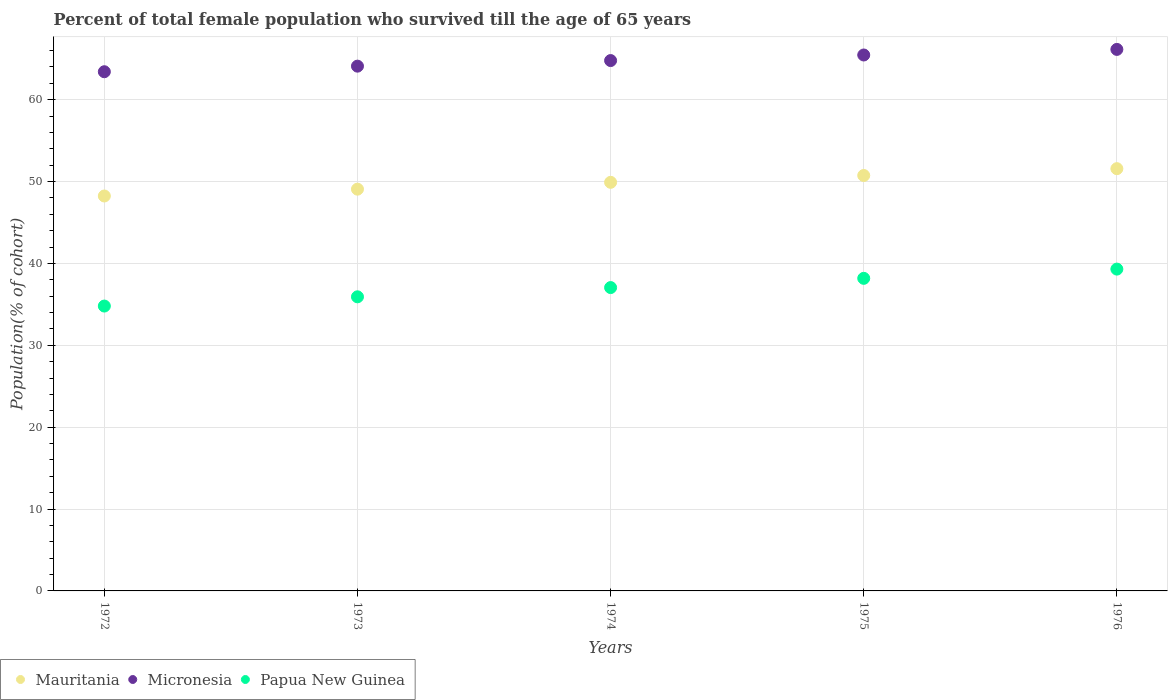What is the percentage of total female population who survived till the age of 65 years in Micronesia in 1976?
Your answer should be compact. 66.14. Across all years, what is the maximum percentage of total female population who survived till the age of 65 years in Papua New Guinea?
Make the answer very short. 39.31. Across all years, what is the minimum percentage of total female population who survived till the age of 65 years in Mauritania?
Give a very brief answer. 48.24. In which year was the percentage of total female population who survived till the age of 65 years in Mauritania maximum?
Your answer should be compact. 1976. What is the total percentage of total female population who survived till the age of 65 years in Mauritania in the graph?
Ensure brevity in your answer.  249.53. What is the difference between the percentage of total female population who survived till the age of 65 years in Micronesia in 1972 and that in 1975?
Offer a very short reply. -2.05. What is the difference between the percentage of total female population who survived till the age of 65 years in Mauritania in 1973 and the percentage of total female population who survived till the age of 65 years in Micronesia in 1974?
Give a very brief answer. -15.71. What is the average percentage of total female population who survived till the age of 65 years in Papua New Guinea per year?
Provide a short and direct response. 37.05. In the year 1975, what is the difference between the percentage of total female population who survived till the age of 65 years in Micronesia and percentage of total female population who survived till the age of 65 years in Mauritania?
Offer a very short reply. 14.72. What is the ratio of the percentage of total female population who survived till the age of 65 years in Papua New Guinea in 1974 to that in 1975?
Offer a very short reply. 0.97. What is the difference between the highest and the second highest percentage of total female population who survived till the age of 65 years in Mauritania?
Provide a short and direct response. 0.83. What is the difference between the highest and the lowest percentage of total female population who survived till the age of 65 years in Micronesia?
Provide a succinct answer. 2.73. Is the sum of the percentage of total female population who survived till the age of 65 years in Papua New Guinea in 1975 and 1976 greater than the maximum percentage of total female population who survived till the age of 65 years in Mauritania across all years?
Offer a very short reply. Yes. Is it the case that in every year, the sum of the percentage of total female population who survived till the age of 65 years in Papua New Guinea and percentage of total female population who survived till the age of 65 years in Mauritania  is greater than the percentage of total female population who survived till the age of 65 years in Micronesia?
Offer a terse response. Yes. Does the percentage of total female population who survived till the age of 65 years in Micronesia monotonically increase over the years?
Make the answer very short. Yes. Is the percentage of total female population who survived till the age of 65 years in Papua New Guinea strictly greater than the percentage of total female population who survived till the age of 65 years in Mauritania over the years?
Ensure brevity in your answer.  No. How many dotlines are there?
Your answer should be compact. 3. How many years are there in the graph?
Offer a very short reply. 5. Are the values on the major ticks of Y-axis written in scientific E-notation?
Offer a terse response. No. Does the graph contain any zero values?
Your answer should be very brief. No. What is the title of the graph?
Offer a terse response. Percent of total female population who survived till the age of 65 years. What is the label or title of the X-axis?
Your answer should be compact. Years. What is the label or title of the Y-axis?
Provide a short and direct response. Population(% of cohort). What is the Population(% of cohort) of Mauritania in 1972?
Make the answer very short. 48.24. What is the Population(% of cohort) of Micronesia in 1972?
Provide a succinct answer. 63.41. What is the Population(% of cohort) in Papua New Guinea in 1972?
Make the answer very short. 34.79. What is the Population(% of cohort) in Mauritania in 1973?
Offer a terse response. 49.07. What is the Population(% of cohort) in Micronesia in 1973?
Your answer should be very brief. 64.1. What is the Population(% of cohort) of Papua New Guinea in 1973?
Offer a very short reply. 35.92. What is the Population(% of cohort) in Mauritania in 1974?
Your answer should be very brief. 49.91. What is the Population(% of cohort) of Micronesia in 1974?
Your answer should be very brief. 64.78. What is the Population(% of cohort) of Papua New Guinea in 1974?
Keep it short and to the point. 37.05. What is the Population(% of cohort) of Mauritania in 1975?
Keep it short and to the point. 50.74. What is the Population(% of cohort) in Micronesia in 1975?
Your answer should be compact. 65.46. What is the Population(% of cohort) in Papua New Guinea in 1975?
Offer a terse response. 38.18. What is the Population(% of cohort) of Mauritania in 1976?
Provide a short and direct response. 51.58. What is the Population(% of cohort) in Micronesia in 1976?
Give a very brief answer. 66.14. What is the Population(% of cohort) of Papua New Guinea in 1976?
Your answer should be very brief. 39.31. Across all years, what is the maximum Population(% of cohort) in Mauritania?
Provide a succinct answer. 51.58. Across all years, what is the maximum Population(% of cohort) in Micronesia?
Your response must be concise. 66.14. Across all years, what is the maximum Population(% of cohort) of Papua New Guinea?
Make the answer very short. 39.31. Across all years, what is the minimum Population(% of cohort) in Mauritania?
Offer a very short reply. 48.24. Across all years, what is the minimum Population(% of cohort) in Micronesia?
Keep it short and to the point. 63.41. Across all years, what is the minimum Population(% of cohort) in Papua New Guinea?
Ensure brevity in your answer.  34.79. What is the total Population(% of cohort) of Mauritania in the graph?
Ensure brevity in your answer.  249.53. What is the total Population(% of cohort) of Micronesia in the graph?
Your answer should be very brief. 323.89. What is the total Population(% of cohort) in Papua New Guinea in the graph?
Give a very brief answer. 185.26. What is the difference between the Population(% of cohort) in Mauritania in 1972 and that in 1973?
Give a very brief answer. -0.83. What is the difference between the Population(% of cohort) of Micronesia in 1972 and that in 1973?
Offer a very short reply. -0.68. What is the difference between the Population(% of cohort) of Papua New Guinea in 1972 and that in 1973?
Make the answer very short. -1.13. What is the difference between the Population(% of cohort) in Mauritania in 1972 and that in 1974?
Offer a very short reply. -1.67. What is the difference between the Population(% of cohort) in Micronesia in 1972 and that in 1974?
Give a very brief answer. -1.36. What is the difference between the Population(% of cohort) of Papua New Guinea in 1972 and that in 1974?
Provide a succinct answer. -2.26. What is the difference between the Population(% of cohort) of Mauritania in 1972 and that in 1975?
Make the answer very short. -2.5. What is the difference between the Population(% of cohort) of Micronesia in 1972 and that in 1975?
Your answer should be compact. -2.05. What is the difference between the Population(% of cohort) in Papua New Guinea in 1972 and that in 1975?
Your answer should be compact. -3.38. What is the difference between the Population(% of cohort) in Mauritania in 1972 and that in 1976?
Provide a short and direct response. -3.34. What is the difference between the Population(% of cohort) of Micronesia in 1972 and that in 1976?
Offer a very short reply. -2.73. What is the difference between the Population(% of cohort) in Papua New Guinea in 1972 and that in 1976?
Offer a terse response. -4.51. What is the difference between the Population(% of cohort) of Mauritania in 1973 and that in 1974?
Make the answer very short. -0.83. What is the difference between the Population(% of cohort) of Micronesia in 1973 and that in 1974?
Your answer should be very brief. -0.68. What is the difference between the Population(% of cohort) of Papua New Guinea in 1973 and that in 1974?
Your response must be concise. -1.13. What is the difference between the Population(% of cohort) in Mauritania in 1973 and that in 1975?
Make the answer very short. -1.67. What is the difference between the Population(% of cohort) of Micronesia in 1973 and that in 1975?
Your answer should be compact. -1.36. What is the difference between the Population(% of cohort) in Papua New Guinea in 1973 and that in 1975?
Your response must be concise. -2.26. What is the difference between the Population(% of cohort) in Mauritania in 1973 and that in 1976?
Keep it short and to the point. -2.5. What is the difference between the Population(% of cohort) in Micronesia in 1973 and that in 1976?
Your answer should be compact. -2.05. What is the difference between the Population(% of cohort) of Papua New Guinea in 1973 and that in 1976?
Provide a succinct answer. -3.38. What is the difference between the Population(% of cohort) of Mauritania in 1974 and that in 1975?
Your answer should be compact. -0.83. What is the difference between the Population(% of cohort) in Micronesia in 1974 and that in 1975?
Offer a very short reply. -0.68. What is the difference between the Population(% of cohort) in Papua New Guinea in 1974 and that in 1975?
Provide a short and direct response. -1.13. What is the difference between the Population(% of cohort) in Mauritania in 1974 and that in 1976?
Keep it short and to the point. -1.67. What is the difference between the Population(% of cohort) of Micronesia in 1974 and that in 1976?
Offer a terse response. -1.36. What is the difference between the Population(% of cohort) in Papua New Guinea in 1974 and that in 1976?
Your answer should be very brief. -2.26. What is the difference between the Population(% of cohort) of Mauritania in 1975 and that in 1976?
Offer a very short reply. -0.83. What is the difference between the Population(% of cohort) of Micronesia in 1975 and that in 1976?
Provide a succinct answer. -0.68. What is the difference between the Population(% of cohort) in Papua New Guinea in 1975 and that in 1976?
Provide a succinct answer. -1.13. What is the difference between the Population(% of cohort) of Mauritania in 1972 and the Population(% of cohort) of Micronesia in 1973?
Provide a succinct answer. -15.86. What is the difference between the Population(% of cohort) of Mauritania in 1972 and the Population(% of cohort) of Papua New Guinea in 1973?
Keep it short and to the point. 12.32. What is the difference between the Population(% of cohort) in Micronesia in 1972 and the Population(% of cohort) in Papua New Guinea in 1973?
Offer a terse response. 27.49. What is the difference between the Population(% of cohort) in Mauritania in 1972 and the Population(% of cohort) in Micronesia in 1974?
Your answer should be very brief. -16.54. What is the difference between the Population(% of cohort) in Mauritania in 1972 and the Population(% of cohort) in Papua New Guinea in 1974?
Offer a terse response. 11.19. What is the difference between the Population(% of cohort) of Micronesia in 1972 and the Population(% of cohort) of Papua New Guinea in 1974?
Ensure brevity in your answer.  26.36. What is the difference between the Population(% of cohort) in Mauritania in 1972 and the Population(% of cohort) in Micronesia in 1975?
Your answer should be compact. -17.22. What is the difference between the Population(% of cohort) of Mauritania in 1972 and the Population(% of cohort) of Papua New Guinea in 1975?
Ensure brevity in your answer.  10.06. What is the difference between the Population(% of cohort) in Micronesia in 1972 and the Population(% of cohort) in Papua New Guinea in 1975?
Make the answer very short. 25.24. What is the difference between the Population(% of cohort) of Mauritania in 1972 and the Population(% of cohort) of Micronesia in 1976?
Your answer should be compact. -17.9. What is the difference between the Population(% of cohort) in Mauritania in 1972 and the Population(% of cohort) in Papua New Guinea in 1976?
Your response must be concise. 8.93. What is the difference between the Population(% of cohort) of Micronesia in 1972 and the Population(% of cohort) of Papua New Guinea in 1976?
Offer a very short reply. 24.11. What is the difference between the Population(% of cohort) in Mauritania in 1973 and the Population(% of cohort) in Micronesia in 1974?
Keep it short and to the point. -15.71. What is the difference between the Population(% of cohort) of Mauritania in 1973 and the Population(% of cohort) of Papua New Guinea in 1974?
Ensure brevity in your answer.  12.02. What is the difference between the Population(% of cohort) in Micronesia in 1973 and the Population(% of cohort) in Papua New Guinea in 1974?
Make the answer very short. 27.05. What is the difference between the Population(% of cohort) of Mauritania in 1973 and the Population(% of cohort) of Micronesia in 1975?
Provide a short and direct response. -16.39. What is the difference between the Population(% of cohort) in Mauritania in 1973 and the Population(% of cohort) in Papua New Guinea in 1975?
Provide a succinct answer. 10.89. What is the difference between the Population(% of cohort) of Micronesia in 1973 and the Population(% of cohort) of Papua New Guinea in 1975?
Your answer should be very brief. 25.92. What is the difference between the Population(% of cohort) of Mauritania in 1973 and the Population(% of cohort) of Micronesia in 1976?
Offer a very short reply. -17.07. What is the difference between the Population(% of cohort) of Mauritania in 1973 and the Population(% of cohort) of Papua New Guinea in 1976?
Offer a very short reply. 9.77. What is the difference between the Population(% of cohort) in Micronesia in 1973 and the Population(% of cohort) in Papua New Guinea in 1976?
Ensure brevity in your answer.  24.79. What is the difference between the Population(% of cohort) in Mauritania in 1974 and the Population(% of cohort) in Micronesia in 1975?
Ensure brevity in your answer.  -15.55. What is the difference between the Population(% of cohort) of Mauritania in 1974 and the Population(% of cohort) of Papua New Guinea in 1975?
Ensure brevity in your answer.  11.73. What is the difference between the Population(% of cohort) of Micronesia in 1974 and the Population(% of cohort) of Papua New Guinea in 1975?
Offer a very short reply. 26.6. What is the difference between the Population(% of cohort) of Mauritania in 1974 and the Population(% of cohort) of Micronesia in 1976?
Provide a succinct answer. -16.23. What is the difference between the Population(% of cohort) in Mauritania in 1974 and the Population(% of cohort) in Papua New Guinea in 1976?
Offer a very short reply. 10.6. What is the difference between the Population(% of cohort) in Micronesia in 1974 and the Population(% of cohort) in Papua New Guinea in 1976?
Your answer should be very brief. 25.47. What is the difference between the Population(% of cohort) of Mauritania in 1975 and the Population(% of cohort) of Micronesia in 1976?
Offer a very short reply. -15.4. What is the difference between the Population(% of cohort) of Mauritania in 1975 and the Population(% of cohort) of Papua New Guinea in 1976?
Keep it short and to the point. 11.43. What is the difference between the Population(% of cohort) of Micronesia in 1975 and the Population(% of cohort) of Papua New Guinea in 1976?
Offer a terse response. 26.15. What is the average Population(% of cohort) in Mauritania per year?
Offer a very short reply. 49.91. What is the average Population(% of cohort) of Micronesia per year?
Your answer should be compact. 64.78. What is the average Population(% of cohort) in Papua New Guinea per year?
Make the answer very short. 37.05. In the year 1972, what is the difference between the Population(% of cohort) of Mauritania and Population(% of cohort) of Micronesia?
Offer a terse response. -15.18. In the year 1972, what is the difference between the Population(% of cohort) of Mauritania and Population(% of cohort) of Papua New Guinea?
Offer a terse response. 13.44. In the year 1972, what is the difference between the Population(% of cohort) of Micronesia and Population(% of cohort) of Papua New Guinea?
Make the answer very short. 28.62. In the year 1973, what is the difference between the Population(% of cohort) of Mauritania and Population(% of cohort) of Micronesia?
Give a very brief answer. -15.02. In the year 1973, what is the difference between the Population(% of cohort) in Mauritania and Population(% of cohort) in Papua New Guinea?
Your response must be concise. 13.15. In the year 1973, what is the difference between the Population(% of cohort) of Micronesia and Population(% of cohort) of Papua New Guinea?
Keep it short and to the point. 28.17. In the year 1974, what is the difference between the Population(% of cohort) of Mauritania and Population(% of cohort) of Micronesia?
Your response must be concise. -14.87. In the year 1974, what is the difference between the Population(% of cohort) in Mauritania and Population(% of cohort) in Papua New Guinea?
Make the answer very short. 12.86. In the year 1974, what is the difference between the Population(% of cohort) of Micronesia and Population(% of cohort) of Papua New Guinea?
Offer a very short reply. 27.73. In the year 1975, what is the difference between the Population(% of cohort) in Mauritania and Population(% of cohort) in Micronesia?
Give a very brief answer. -14.72. In the year 1975, what is the difference between the Population(% of cohort) in Mauritania and Population(% of cohort) in Papua New Guinea?
Keep it short and to the point. 12.56. In the year 1975, what is the difference between the Population(% of cohort) in Micronesia and Population(% of cohort) in Papua New Guinea?
Offer a very short reply. 27.28. In the year 1976, what is the difference between the Population(% of cohort) in Mauritania and Population(% of cohort) in Micronesia?
Give a very brief answer. -14.57. In the year 1976, what is the difference between the Population(% of cohort) of Mauritania and Population(% of cohort) of Papua New Guinea?
Provide a succinct answer. 12.27. In the year 1976, what is the difference between the Population(% of cohort) of Micronesia and Population(% of cohort) of Papua New Guinea?
Ensure brevity in your answer.  26.83. What is the ratio of the Population(% of cohort) in Mauritania in 1972 to that in 1973?
Provide a succinct answer. 0.98. What is the ratio of the Population(% of cohort) in Micronesia in 1972 to that in 1973?
Offer a very short reply. 0.99. What is the ratio of the Population(% of cohort) of Papua New Guinea in 1972 to that in 1973?
Keep it short and to the point. 0.97. What is the ratio of the Population(% of cohort) of Mauritania in 1972 to that in 1974?
Offer a terse response. 0.97. What is the ratio of the Population(% of cohort) of Papua New Guinea in 1972 to that in 1974?
Your answer should be very brief. 0.94. What is the ratio of the Population(% of cohort) in Mauritania in 1972 to that in 1975?
Your response must be concise. 0.95. What is the ratio of the Population(% of cohort) of Micronesia in 1972 to that in 1975?
Give a very brief answer. 0.97. What is the ratio of the Population(% of cohort) of Papua New Guinea in 1972 to that in 1975?
Offer a very short reply. 0.91. What is the ratio of the Population(% of cohort) of Mauritania in 1972 to that in 1976?
Give a very brief answer. 0.94. What is the ratio of the Population(% of cohort) in Micronesia in 1972 to that in 1976?
Ensure brevity in your answer.  0.96. What is the ratio of the Population(% of cohort) in Papua New Guinea in 1972 to that in 1976?
Offer a very short reply. 0.89. What is the ratio of the Population(% of cohort) in Mauritania in 1973 to that in 1974?
Make the answer very short. 0.98. What is the ratio of the Population(% of cohort) in Papua New Guinea in 1973 to that in 1974?
Keep it short and to the point. 0.97. What is the ratio of the Population(% of cohort) in Mauritania in 1973 to that in 1975?
Ensure brevity in your answer.  0.97. What is the ratio of the Population(% of cohort) in Micronesia in 1973 to that in 1975?
Offer a very short reply. 0.98. What is the ratio of the Population(% of cohort) of Papua New Guinea in 1973 to that in 1975?
Your answer should be very brief. 0.94. What is the ratio of the Population(% of cohort) of Mauritania in 1973 to that in 1976?
Offer a very short reply. 0.95. What is the ratio of the Population(% of cohort) in Micronesia in 1973 to that in 1976?
Your answer should be very brief. 0.97. What is the ratio of the Population(% of cohort) of Papua New Guinea in 1973 to that in 1976?
Provide a succinct answer. 0.91. What is the ratio of the Population(% of cohort) of Mauritania in 1974 to that in 1975?
Give a very brief answer. 0.98. What is the ratio of the Population(% of cohort) in Papua New Guinea in 1974 to that in 1975?
Ensure brevity in your answer.  0.97. What is the ratio of the Population(% of cohort) of Mauritania in 1974 to that in 1976?
Keep it short and to the point. 0.97. What is the ratio of the Population(% of cohort) in Micronesia in 1974 to that in 1976?
Ensure brevity in your answer.  0.98. What is the ratio of the Population(% of cohort) in Papua New Guinea in 1974 to that in 1976?
Offer a terse response. 0.94. What is the ratio of the Population(% of cohort) in Mauritania in 1975 to that in 1976?
Offer a terse response. 0.98. What is the ratio of the Population(% of cohort) in Papua New Guinea in 1975 to that in 1976?
Your answer should be very brief. 0.97. What is the difference between the highest and the second highest Population(% of cohort) of Mauritania?
Provide a short and direct response. 0.83. What is the difference between the highest and the second highest Population(% of cohort) in Micronesia?
Ensure brevity in your answer.  0.68. What is the difference between the highest and the second highest Population(% of cohort) in Papua New Guinea?
Offer a terse response. 1.13. What is the difference between the highest and the lowest Population(% of cohort) in Mauritania?
Make the answer very short. 3.34. What is the difference between the highest and the lowest Population(% of cohort) in Micronesia?
Offer a very short reply. 2.73. What is the difference between the highest and the lowest Population(% of cohort) in Papua New Guinea?
Make the answer very short. 4.51. 